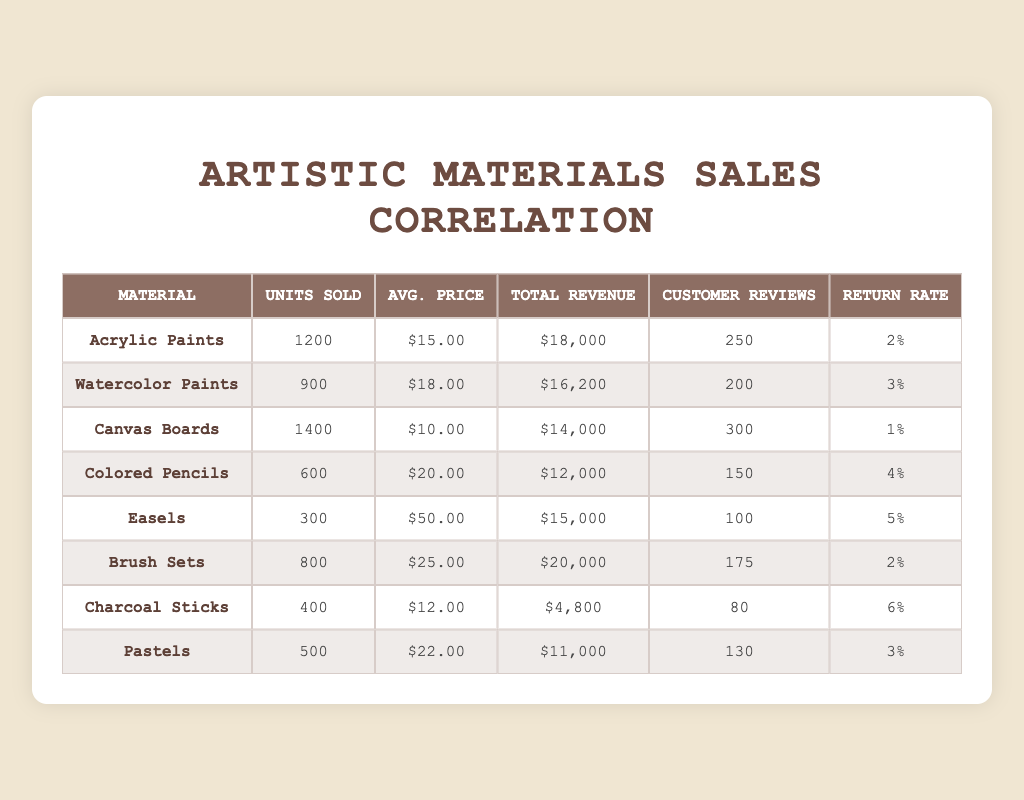What material had the highest units sold? By reviewing the "Units Sold" column, "Canvas Boards" has the highest value at 1400 units sold.
Answer: Canvas Boards What was the total revenue for Brush Sets? The "Total Revenue" column indicates that Brush Sets generated $20,000 in revenue.
Answer: $20,000 Is the return rate for Charcoal Sticks higher than for Acrylic Paints? Looking at the "Return Rate" column, Charcoal Sticks has a return rate of 6%, whereas Acrylic Paints has a return rate of 2%. Since 6% is greater than 2%, the answer is yes.
Answer: Yes What is the average price of all the materials combined? To find the average price, sum up the average prices of all materials ($15.00 + $18.00 + $10.00 + $20.00 + $50.00 + $25.00 + $12.00 + $22.00 = $152.00) and then divide by the number of materials (8): $152.00 / 8 = $19.00.
Answer: $19.00 Do more customer reviews correlate with a lower return rate? To analyze this, look at customer reviews and return rates for materials. For example, Canvas Boards have 300 reviews and a 1% return rate, while Charcoal Sticks have 80 reviews and a 6% return rate. This indicates that higher customer reviews seem to correlate with lower return rates.
Answer: Yes Which material sold the least units and what was its total revenue? The material that sold the least units is "Easels" with 300 units sold, generating a total revenue of $15,000 as per the respective columns.
Answer: Easels, $15,000 What is the difference in total revenue between Acrylic Paints and Watercolor Paints? Acrylic Paints generated $18,000, and Watercolor Paints generated $16,200. Subtracting these gives $18,000 - $16,200 = $1,800. Thus, the difference in total revenue is $1,800.
Answer: $1,800 Which material had the highest average price per unit? Examining the "Avg. Price" column, "Easels" has the highest average price at $50.00.
Answer: Easels What percentage of total units sold do Colored Pencils represent? First, calculate total units sold: 1200 + 900 + 1400 + 600 + 300 + 800 + 400 + 500 = 5100. Then, for Colored Pencils, which sold 600 units, the percentage is (600 / 5100) * 100 ≈ 11.76%.
Answer: 11.76% 